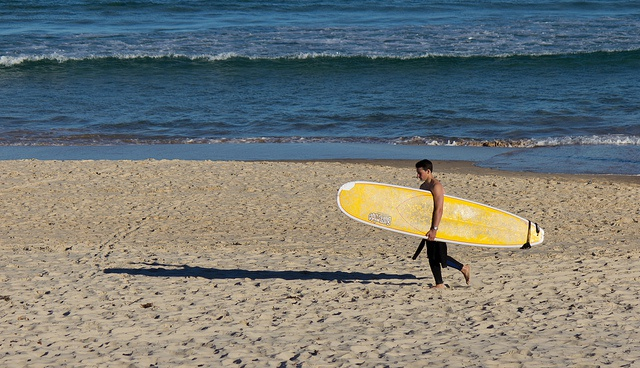Describe the objects in this image and their specific colors. I can see surfboard in darkblue, tan, gold, and lightgray tones and people in darkblue, black, brown, maroon, and tan tones in this image. 